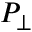<formula> <loc_0><loc_0><loc_500><loc_500>P _ { \perp }</formula> 